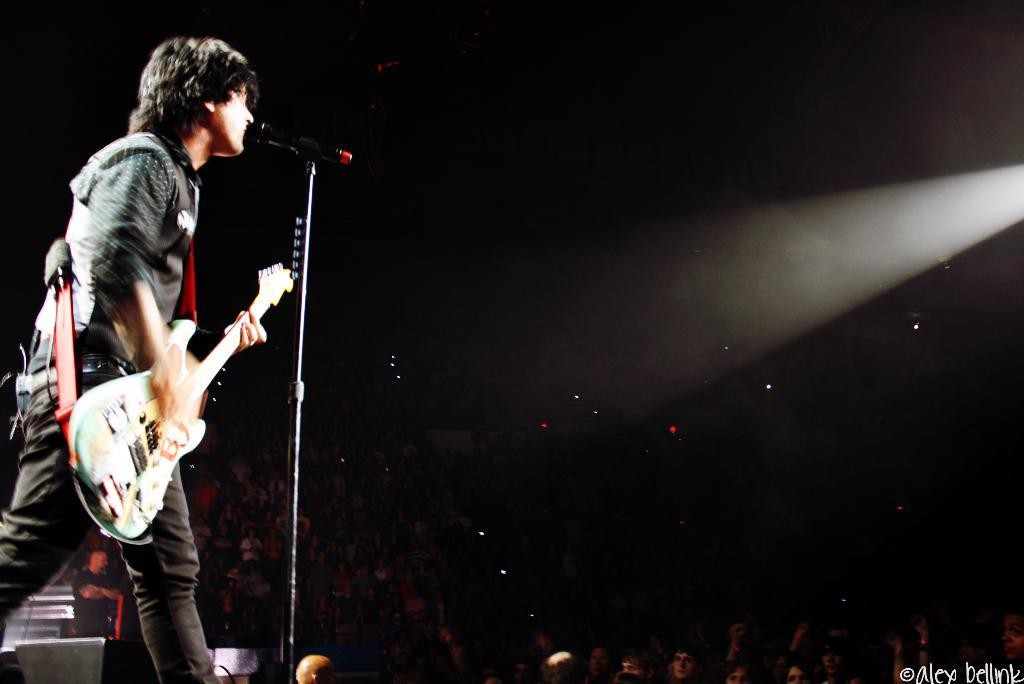What is the man in the image holding? The man in the image is holding a guitar. What is the man doing with the guitar? The man is standing and singing near a microphone while holding the guitar. Where is the man located in the image? The man is on the left side of the image. Who is the man performing for in the image? The man is performing for a crowd visible in the image. Where is the crowd located in the image? The crowd is at the bottom of the image. What can be seen on the right side of the image? There is a light on the right side of the image. What is the value of the list of flesh in the image? There is no list of flesh or any reference to value in the image. 